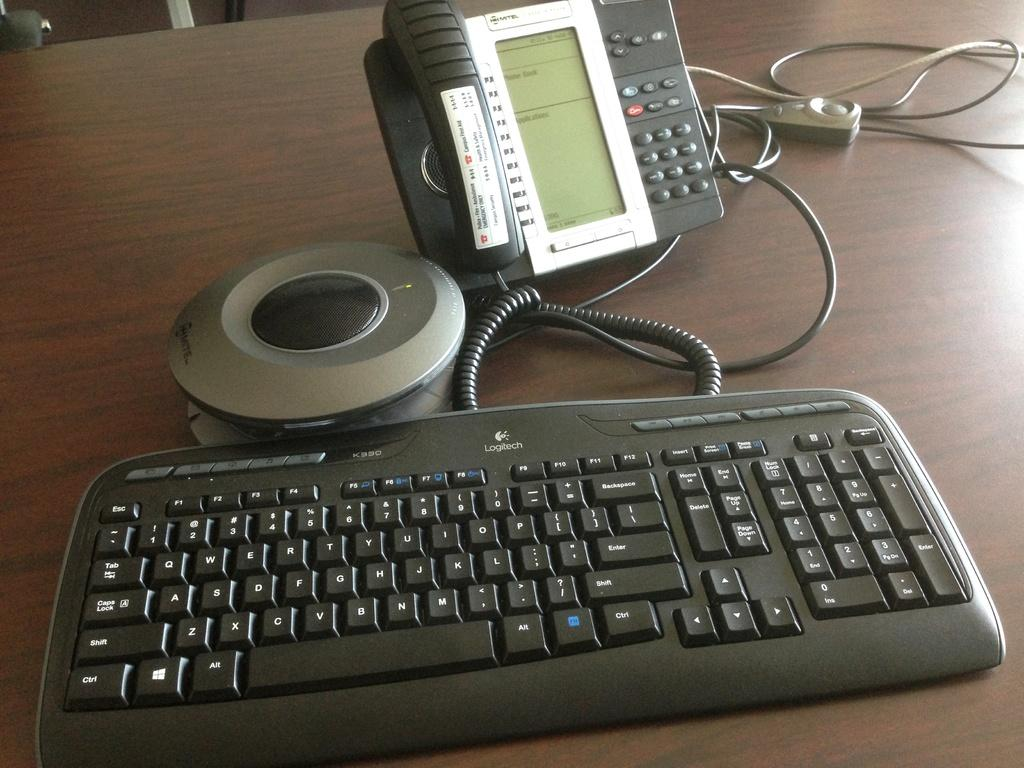What electronic device is visible in the image? There is a keyboard in the image. What other electronic device can be seen in the image? There is a telephone in the image. What else is present in the image besides the electronic devices? There are wires and an object on the table in the image. Can you describe the unspecified objects in the image? Unfortunately, the facts provided do not specify the nature of the unspecified objects in the image. How many cakes are balanced on the telephone in the image? There are no cakes present in the image, and the telephone is not being used to balance anything. 